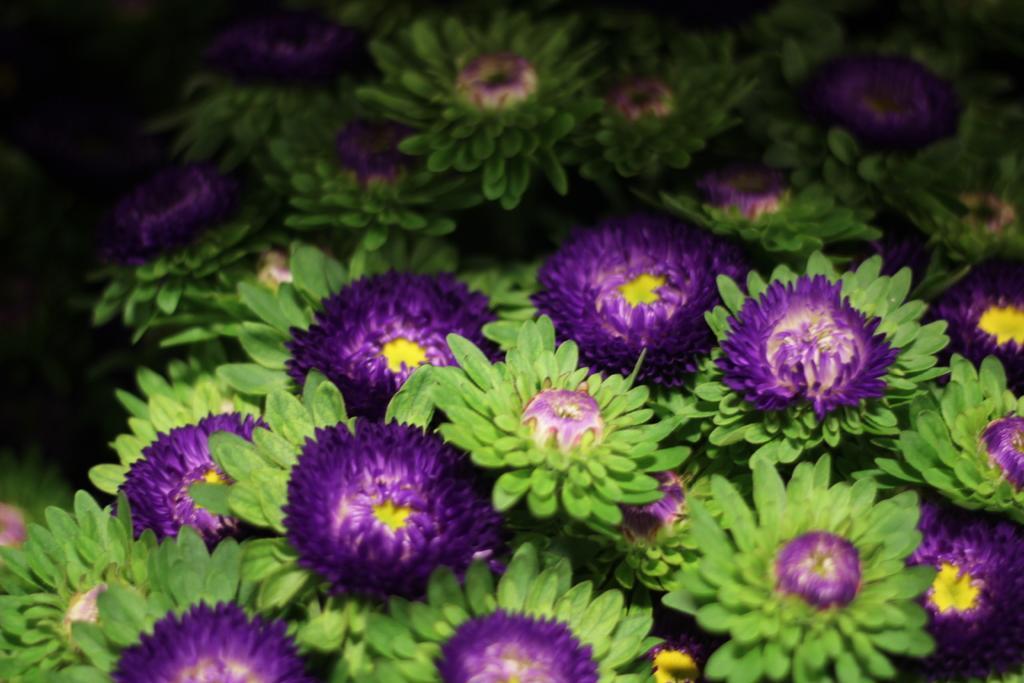Please provide a concise description of this image. In the foreground of this image, there are violet color flowers and buds with green leaves. 